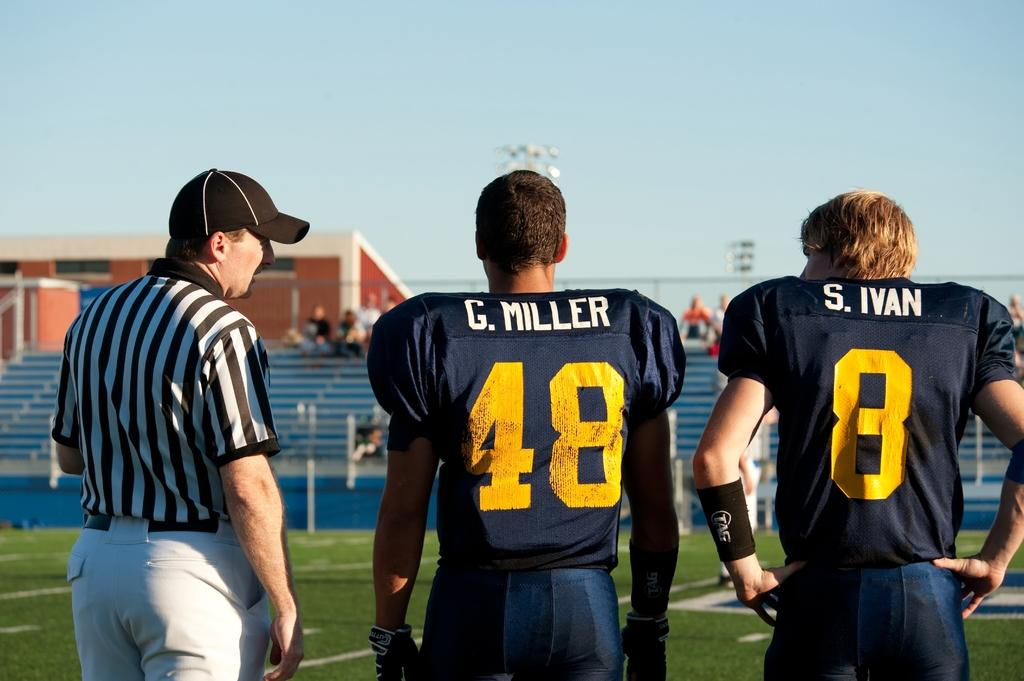<image>
Render a clear and concise summary of the photo. G. Miller is number 48 on his football team. 